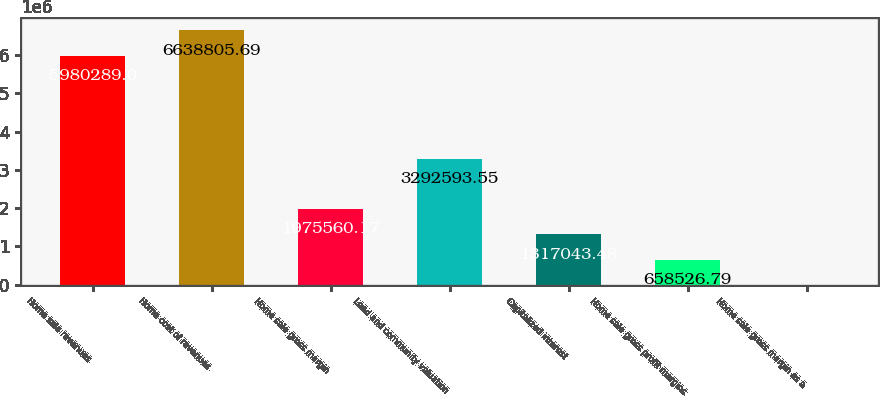<chart> <loc_0><loc_0><loc_500><loc_500><bar_chart><fcel>Home sale revenues<fcel>Home cost of revenues<fcel>Home sale gross margin<fcel>Land and community valuation<fcel>Capitalized interest<fcel>Home sale gross profit margins<fcel>Home sale gross margin as a<nl><fcel>5.98029e+06<fcel>6.63881e+06<fcel>1.97556e+06<fcel>3.29259e+06<fcel>1.31704e+06<fcel>658527<fcel>10.1<nl></chart> 